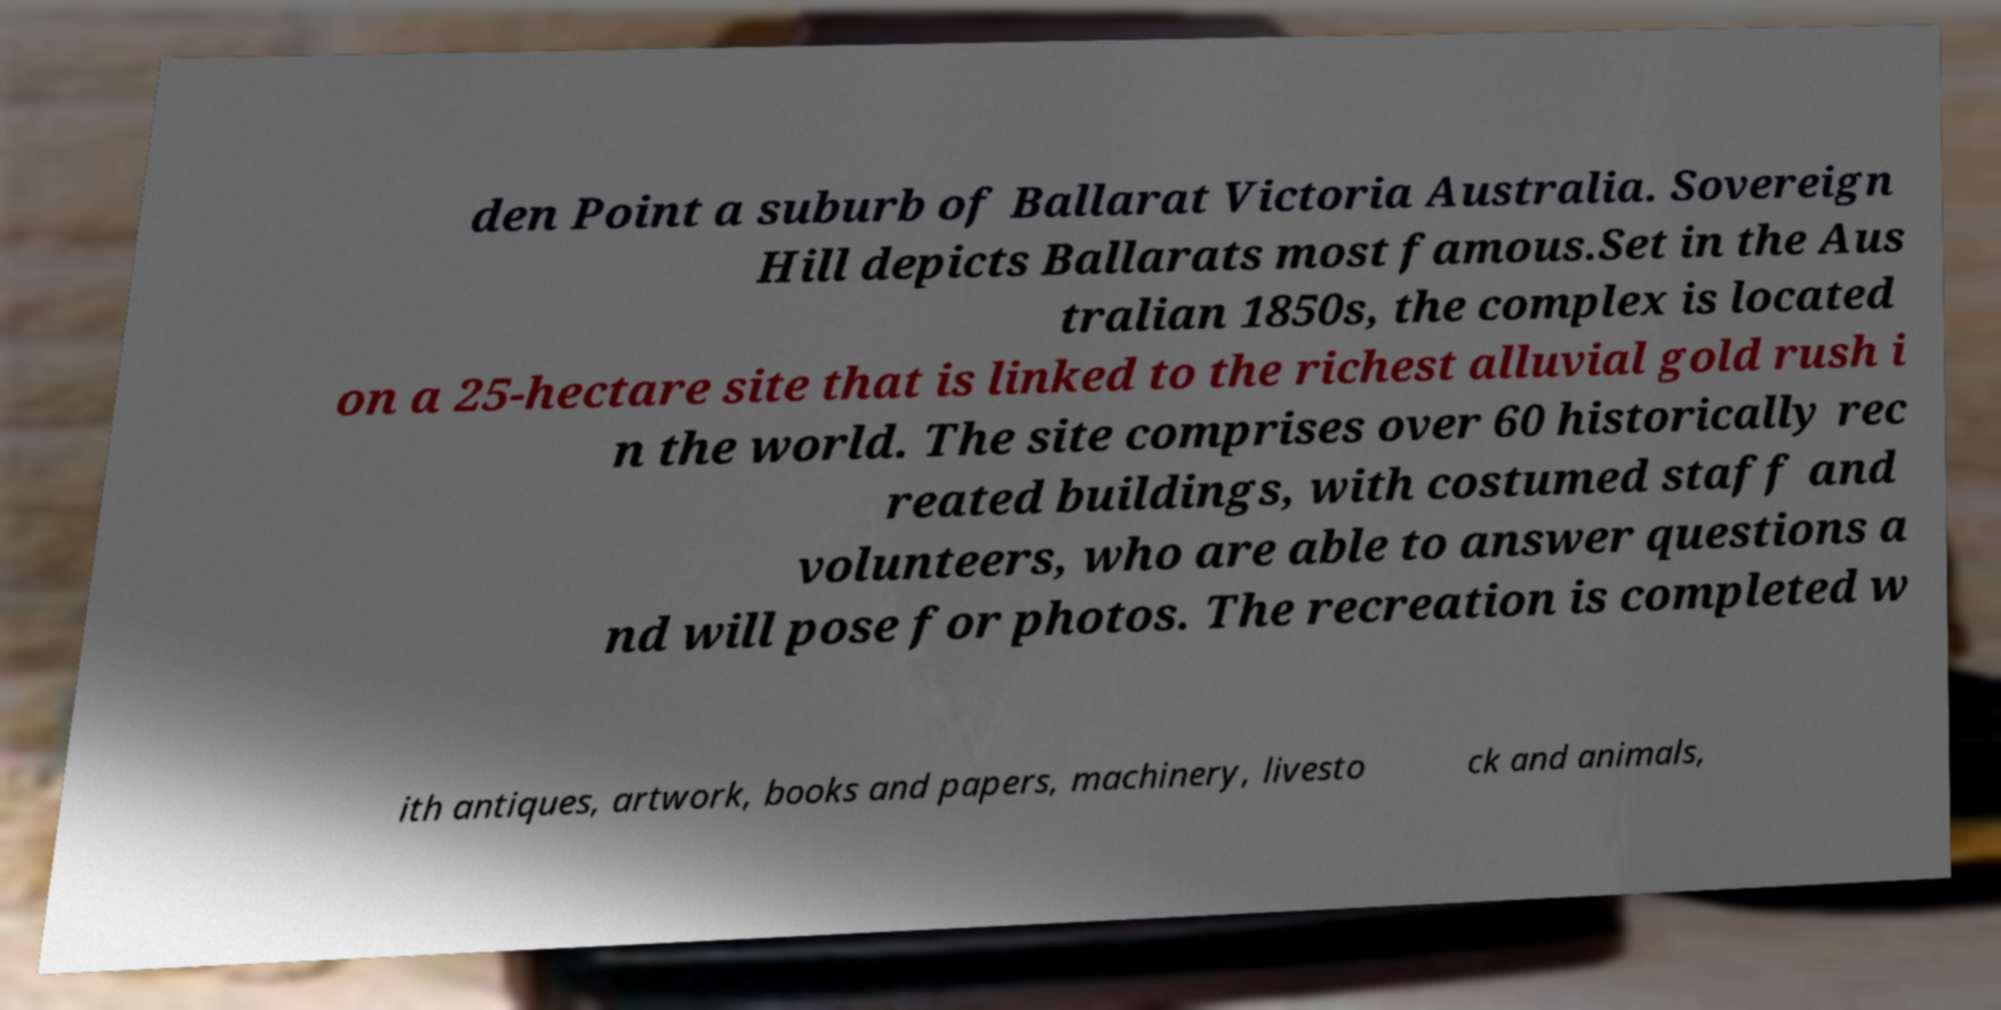There's text embedded in this image that I need extracted. Can you transcribe it verbatim? den Point a suburb of Ballarat Victoria Australia. Sovereign Hill depicts Ballarats most famous.Set in the Aus tralian 1850s, the complex is located on a 25-hectare site that is linked to the richest alluvial gold rush i n the world. The site comprises over 60 historically rec reated buildings, with costumed staff and volunteers, who are able to answer questions a nd will pose for photos. The recreation is completed w ith antiques, artwork, books and papers, machinery, livesto ck and animals, 